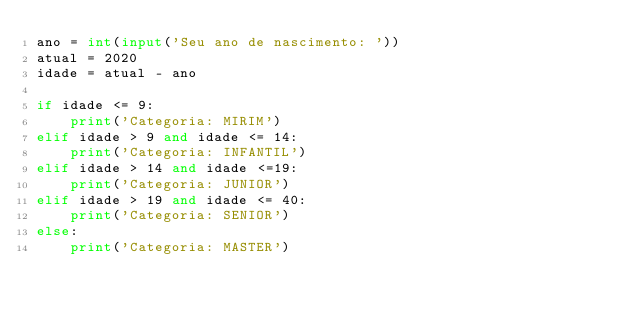<code> <loc_0><loc_0><loc_500><loc_500><_Python_>ano = int(input('Seu ano de nascimento: '))
atual = 2020
idade = atual - ano

if idade <= 9:
    print('Categoria: MIRIM')
elif idade > 9 and idade <= 14:
    print('Categoria: INFANTIL')
elif idade > 14 and idade <=19:
    print('Categoria: JUNIOR')
elif idade > 19 and idade <= 40:
    print('Categoria: SENIOR')
else:
    print('Categoria: MASTER')
</code> 